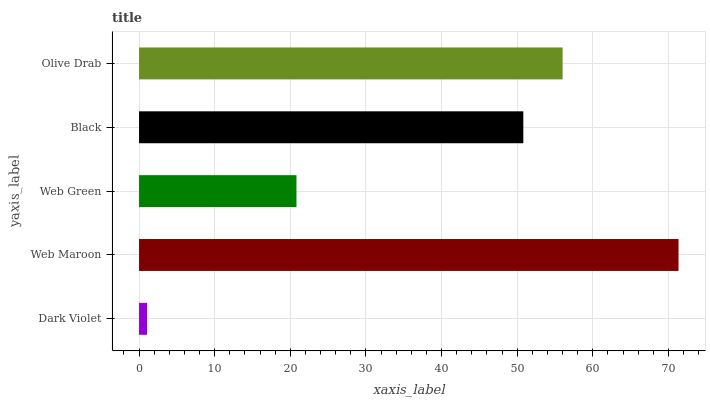Is Dark Violet the minimum?
Answer yes or no. Yes. Is Web Maroon the maximum?
Answer yes or no. Yes. Is Web Green the minimum?
Answer yes or no. No. Is Web Green the maximum?
Answer yes or no. No. Is Web Maroon greater than Web Green?
Answer yes or no. Yes. Is Web Green less than Web Maroon?
Answer yes or no. Yes. Is Web Green greater than Web Maroon?
Answer yes or no. No. Is Web Maroon less than Web Green?
Answer yes or no. No. Is Black the high median?
Answer yes or no. Yes. Is Black the low median?
Answer yes or no. Yes. Is Web Green the high median?
Answer yes or no. No. Is Web Green the low median?
Answer yes or no. No. 